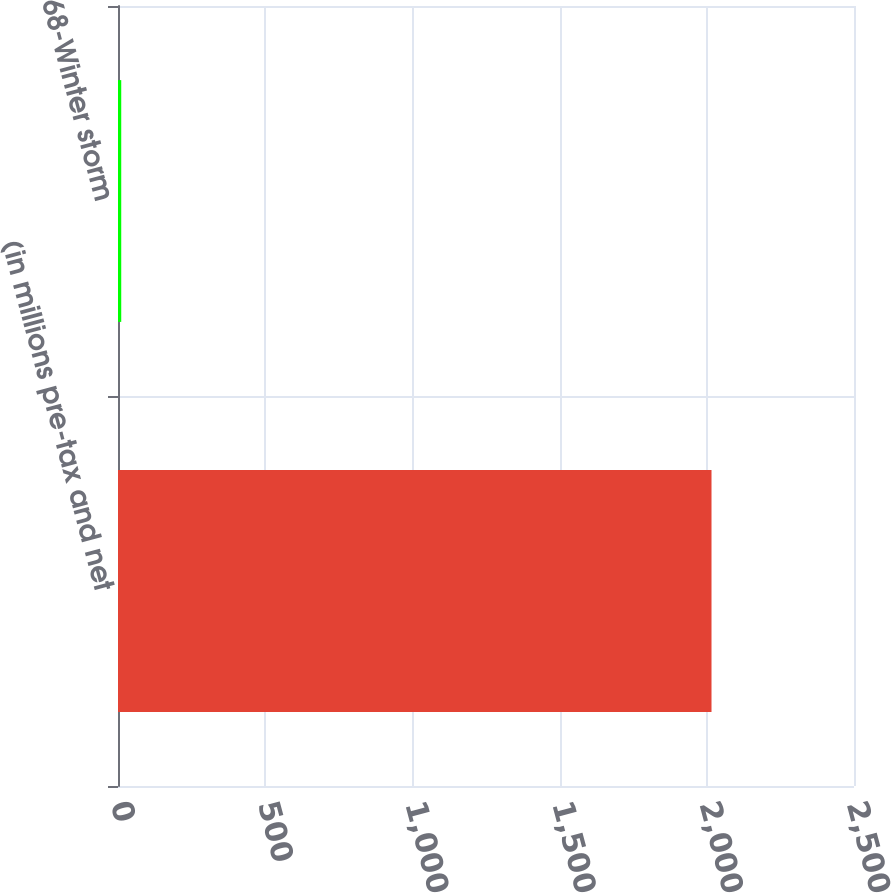Convert chart. <chart><loc_0><loc_0><loc_500><loc_500><bar_chart><fcel>(in millions pre-tax and net<fcel>68-Winter storm<nl><fcel>2016<fcel>11<nl></chart> 